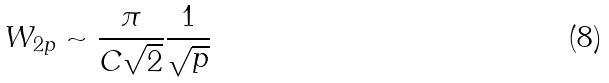<formula> <loc_0><loc_0><loc_500><loc_500>W _ { 2 p } \sim \frac { \pi } { C \sqrt { 2 } } \frac { 1 } { \sqrt { p } }</formula> 